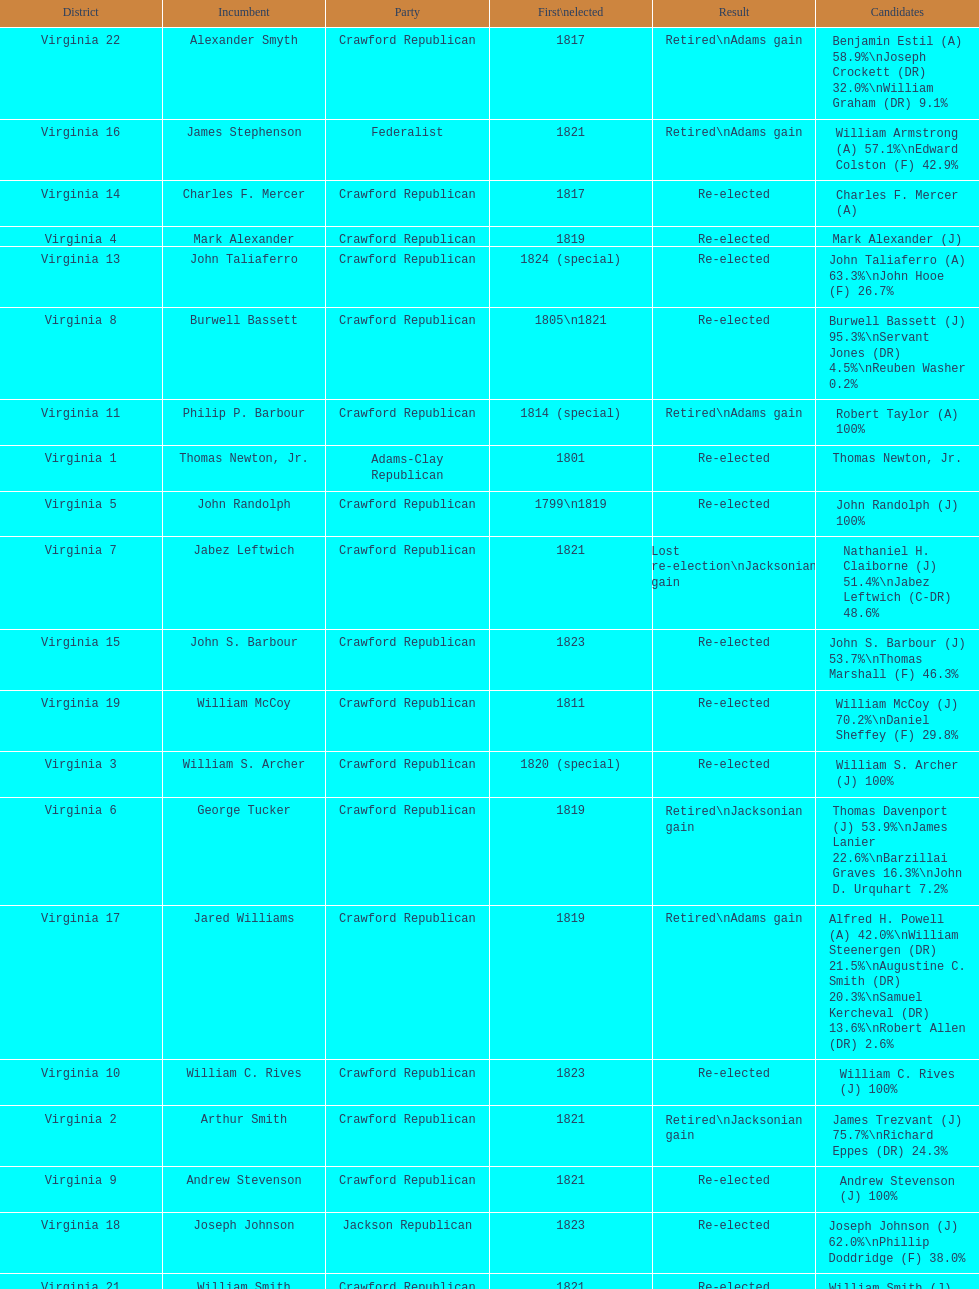Could you help me parse every detail presented in this table? {'header': ['District', 'Incumbent', 'Party', 'First\\nelected', 'Result', 'Candidates'], 'rows': [['Virginia 22', 'Alexander Smyth', 'Crawford Republican', '1817', 'Retired\\nAdams gain', 'Benjamin Estil (A) 58.9%\\nJoseph Crockett (DR) 32.0%\\nWilliam Graham (DR) 9.1%'], ['Virginia 16', 'James Stephenson', 'Federalist', '1821', 'Retired\\nAdams gain', 'William Armstrong (A) 57.1%\\nEdward Colston (F) 42.9%'], ['Virginia 14', 'Charles F. Mercer', 'Crawford Republican', '1817', 'Re-elected', 'Charles F. Mercer (A)'], ['Virginia 4', 'Mark Alexander', 'Crawford Republican', '1819', 'Re-elected', 'Mark Alexander (J)'], ['Virginia 13', 'John Taliaferro', 'Crawford Republican', '1824 (special)', 'Re-elected', 'John Taliaferro (A) 63.3%\\nJohn Hooe (F) 26.7%'], ['Virginia 8', 'Burwell Bassett', 'Crawford Republican', '1805\\n1821', 'Re-elected', 'Burwell Bassett (J) 95.3%\\nServant Jones (DR) 4.5%\\nReuben Washer 0.2%'], ['Virginia 11', 'Philip P. Barbour', 'Crawford Republican', '1814 (special)', 'Retired\\nAdams gain', 'Robert Taylor (A) 100%'], ['Virginia 1', 'Thomas Newton, Jr.', 'Adams-Clay Republican', '1801', 'Re-elected', 'Thomas Newton, Jr.'], ['Virginia 5', 'John Randolph', 'Crawford Republican', '1799\\n1819', 'Re-elected', 'John Randolph (J) 100%'], ['Virginia 7', 'Jabez Leftwich', 'Crawford Republican', '1821', 'Lost re-election\\nJacksonian gain', 'Nathaniel H. Claiborne (J) 51.4%\\nJabez Leftwich (C-DR) 48.6%'], ['Virginia 15', 'John S. Barbour', 'Crawford Republican', '1823', 'Re-elected', 'John S. Barbour (J) 53.7%\\nThomas Marshall (F) 46.3%'], ['Virginia 19', 'William McCoy', 'Crawford Republican', '1811', 'Re-elected', 'William McCoy (J) 70.2%\\nDaniel Sheffey (F) 29.8%'], ['Virginia 3', 'William S. Archer', 'Crawford Republican', '1820 (special)', 'Re-elected', 'William S. Archer (J) 100%'], ['Virginia 6', 'George Tucker', 'Crawford Republican', '1819', 'Retired\\nJacksonian gain', 'Thomas Davenport (J) 53.9%\\nJames Lanier 22.6%\\nBarzillai Graves 16.3%\\nJohn D. Urquhart 7.2%'], ['Virginia 17', 'Jared Williams', 'Crawford Republican', '1819', 'Retired\\nAdams gain', 'Alfred H. Powell (A) 42.0%\\nWilliam Steenergen (DR) 21.5%\\nAugustine C. Smith (DR) 20.3%\\nSamuel Kercheval (DR) 13.6%\\nRobert Allen (DR) 2.6%'], ['Virginia 10', 'William C. Rives', 'Crawford Republican', '1823', 'Re-elected', 'William C. Rives (J) 100%'], ['Virginia 2', 'Arthur Smith', 'Crawford Republican', '1821', 'Retired\\nJacksonian gain', 'James Trezvant (J) 75.7%\\nRichard Eppes (DR) 24.3%'], ['Virginia 9', 'Andrew Stevenson', 'Crawford Republican', '1821', 'Re-elected', 'Andrew Stevenson (J) 100%'], ['Virginia 18', 'Joseph Johnson', 'Jackson Republican', '1823', 'Re-elected', 'Joseph Johnson (J) 62.0%\\nPhillip Doddridge (F) 38.0%'], ['Virginia 21', 'William Smith', 'Crawford Republican', '1821', 'Re-elected', 'William Smith (J) 55.2%\\nJames Lovell (DR) 44.8%'], ['Virginia 20', 'John Floyd', 'Crawford Republican', '1817', 'Re-elected', 'John Floyd (J) 84.7%\\nAllen Taylor (F) 15.3%'], ['Virginia 12', 'Robert S. Garnett', 'Crawford Republican', '1817', 'Re-elected', 'Robert S. Garnett (J) 68.5%\\nJohn H. Upshaw 31.5%']]} How many districts are there in virginia? 22. 